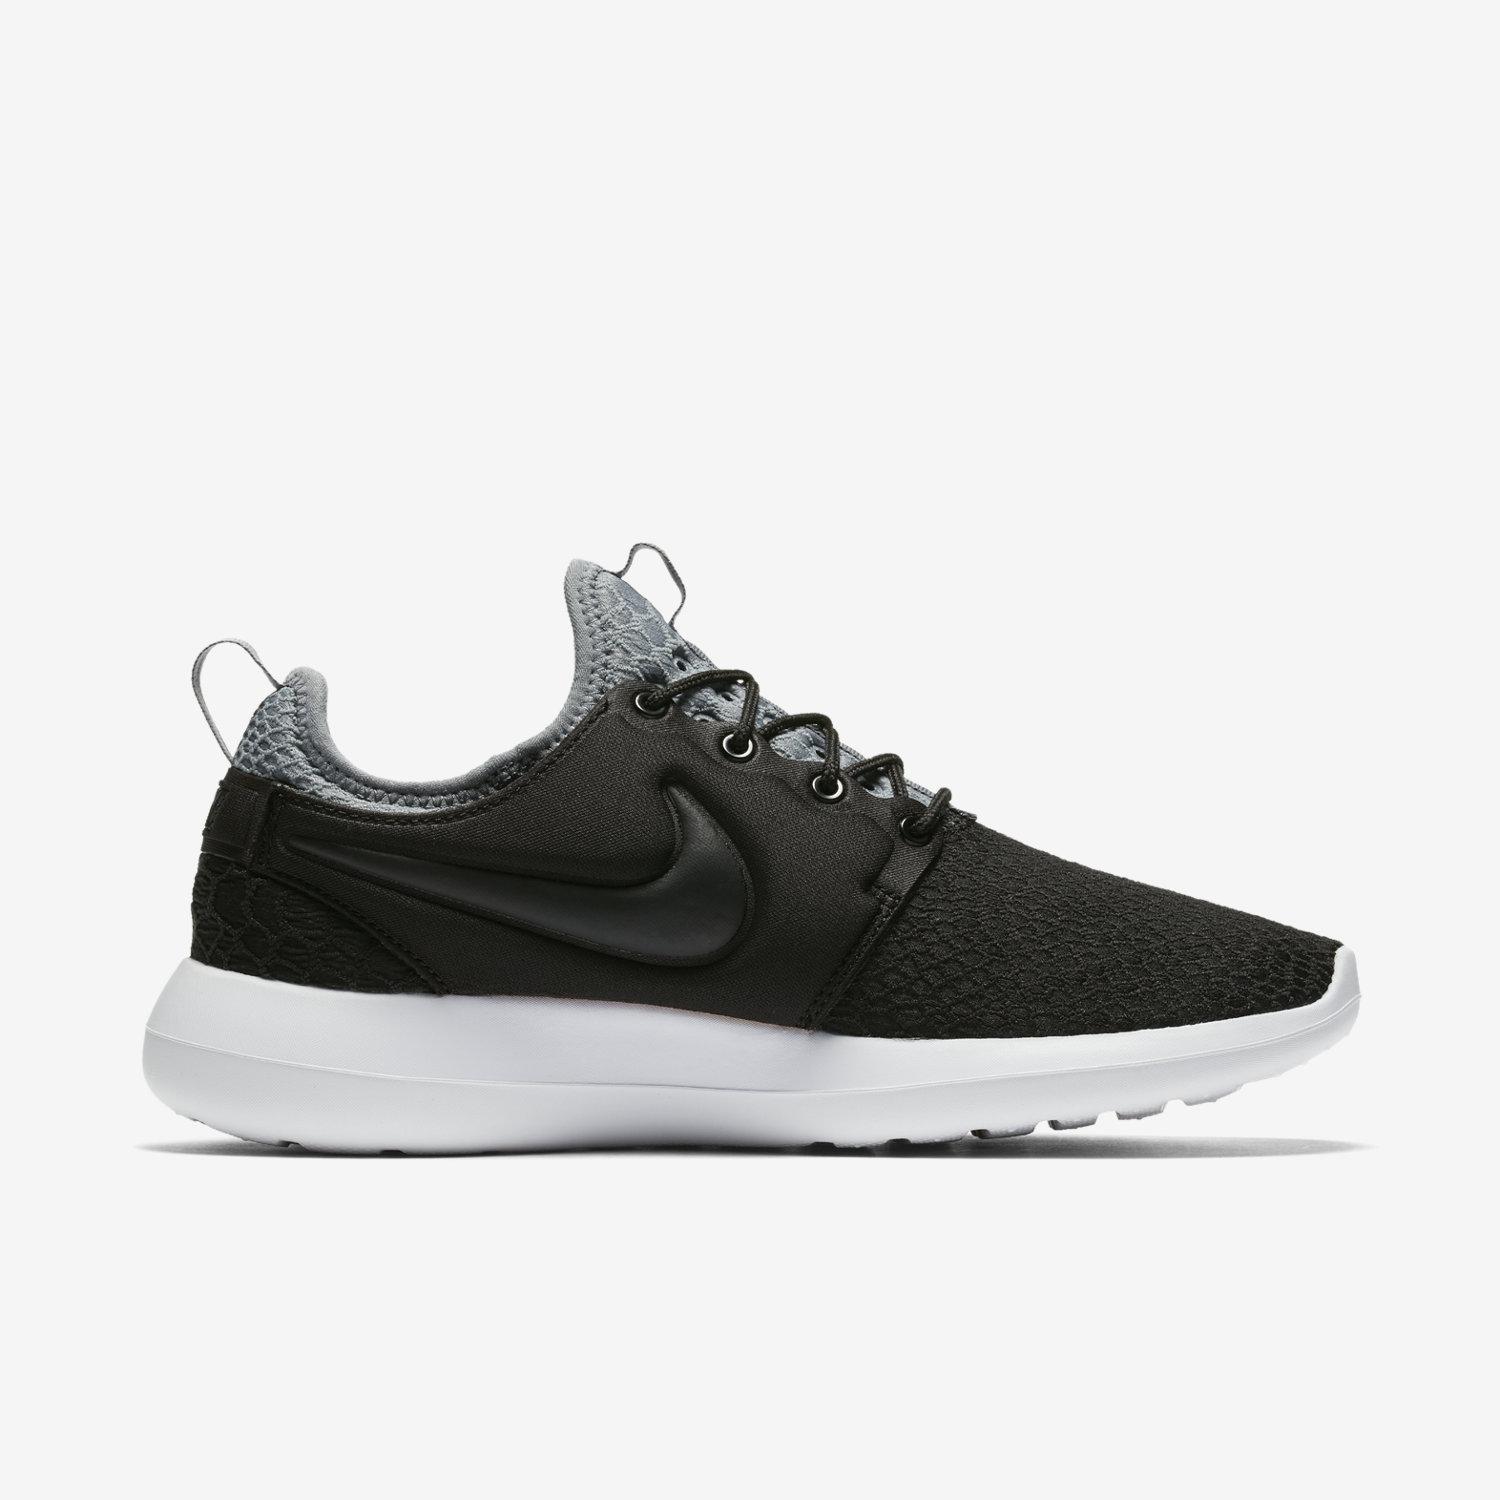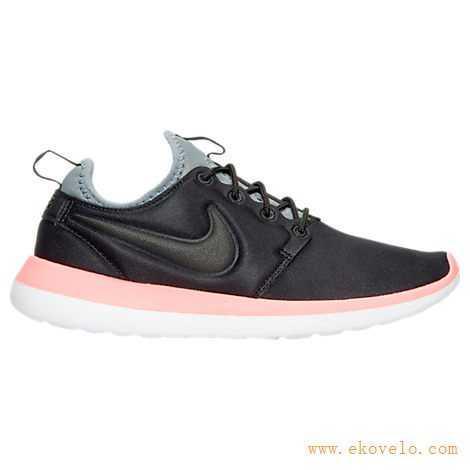The first image is the image on the left, the second image is the image on the right. Considering the images on both sides, is "Both shoes have a gray tongue." valid? Answer yes or no. Yes. The first image is the image on the left, the second image is the image on the right. Evaluate the accuracy of this statement regarding the images: "Each set features shoes that are dramatically different in color or design.". Is it true? Answer yes or no. No. 